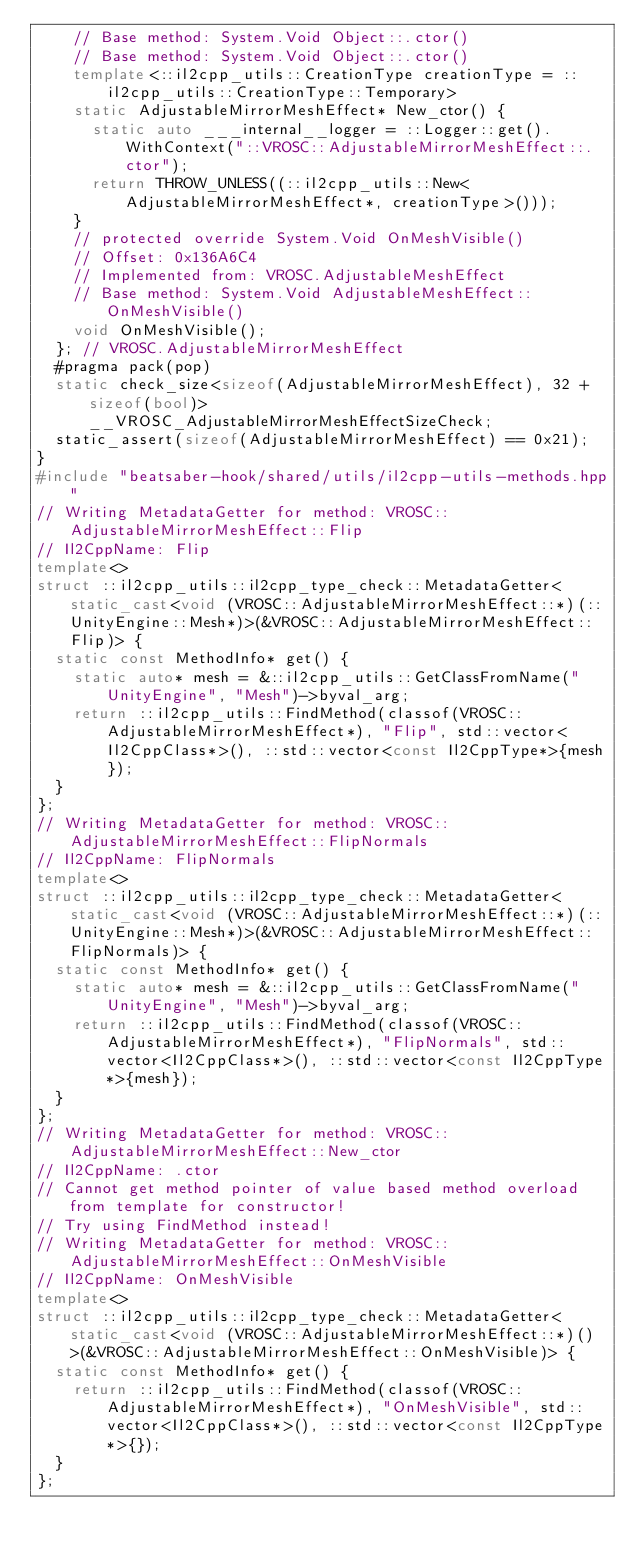<code> <loc_0><loc_0><loc_500><loc_500><_C++_>    // Base method: System.Void Object::.ctor()
    // Base method: System.Void Object::.ctor()
    template<::il2cpp_utils::CreationType creationType = ::il2cpp_utils::CreationType::Temporary>
    static AdjustableMirrorMeshEffect* New_ctor() {
      static auto ___internal__logger = ::Logger::get().WithContext("::VROSC::AdjustableMirrorMeshEffect::.ctor");
      return THROW_UNLESS((::il2cpp_utils::New<AdjustableMirrorMeshEffect*, creationType>()));
    }
    // protected override System.Void OnMeshVisible()
    // Offset: 0x136A6C4
    // Implemented from: VROSC.AdjustableMeshEffect
    // Base method: System.Void AdjustableMeshEffect::OnMeshVisible()
    void OnMeshVisible();
  }; // VROSC.AdjustableMirrorMeshEffect
  #pragma pack(pop)
  static check_size<sizeof(AdjustableMirrorMeshEffect), 32 + sizeof(bool)> __VROSC_AdjustableMirrorMeshEffectSizeCheck;
  static_assert(sizeof(AdjustableMirrorMeshEffect) == 0x21);
}
#include "beatsaber-hook/shared/utils/il2cpp-utils-methods.hpp"
// Writing MetadataGetter for method: VROSC::AdjustableMirrorMeshEffect::Flip
// Il2CppName: Flip
template<>
struct ::il2cpp_utils::il2cpp_type_check::MetadataGetter<static_cast<void (VROSC::AdjustableMirrorMeshEffect::*)(::UnityEngine::Mesh*)>(&VROSC::AdjustableMirrorMeshEffect::Flip)> {
  static const MethodInfo* get() {
    static auto* mesh = &::il2cpp_utils::GetClassFromName("UnityEngine", "Mesh")->byval_arg;
    return ::il2cpp_utils::FindMethod(classof(VROSC::AdjustableMirrorMeshEffect*), "Flip", std::vector<Il2CppClass*>(), ::std::vector<const Il2CppType*>{mesh});
  }
};
// Writing MetadataGetter for method: VROSC::AdjustableMirrorMeshEffect::FlipNormals
// Il2CppName: FlipNormals
template<>
struct ::il2cpp_utils::il2cpp_type_check::MetadataGetter<static_cast<void (VROSC::AdjustableMirrorMeshEffect::*)(::UnityEngine::Mesh*)>(&VROSC::AdjustableMirrorMeshEffect::FlipNormals)> {
  static const MethodInfo* get() {
    static auto* mesh = &::il2cpp_utils::GetClassFromName("UnityEngine", "Mesh")->byval_arg;
    return ::il2cpp_utils::FindMethod(classof(VROSC::AdjustableMirrorMeshEffect*), "FlipNormals", std::vector<Il2CppClass*>(), ::std::vector<const Il2CppType*>{mesh});
  }
};
// Writing MetadataGetter for method: VROSC::AdjustableMirrorMeshEffect::New_ctor
// Il2CppName: .ctor
// Cannot get method pointer of value based method overload from template for constructor!
// Try using FindMethod instead!
// Writing MetadataGetter for method: VROSC::AdjustableMirrorMeshEffect::OnMeshVisible
// Il2CppName: OnMeshVisible
template<>
struct ::il2cpp_utils::il2cpp_type_check::MetadataGetter<static_cast<void (VROSC::AdjustableMirrorMeshEffect::*)()>(&VROSC::AdjustableMirrorMeshEffect::OnMeshVisible)> {
  static const MethodInfo* get() {
    return ::il2cpp_utils::FindMethod(classof(VROSC::AdjustableMirrorMeshEffect*), "OnMeshVisible", std::vector<Il2CppClass*>(), ::std::vector<const Il2CppType*>{});
  }
};
</code> 